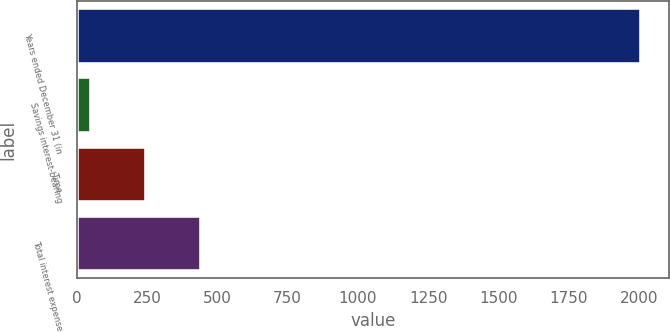<chart> <loc_0><loc_0><loc_500><loc_500><bar_chart><fcel>Years ended December 31 (in<fcel>Savings interest-bearing<fcel>Time<fcel>Total interest expense<nl><fcel>2006<fcel>49.6<fcel>245.24<fcel>440.88<nl></chart> 